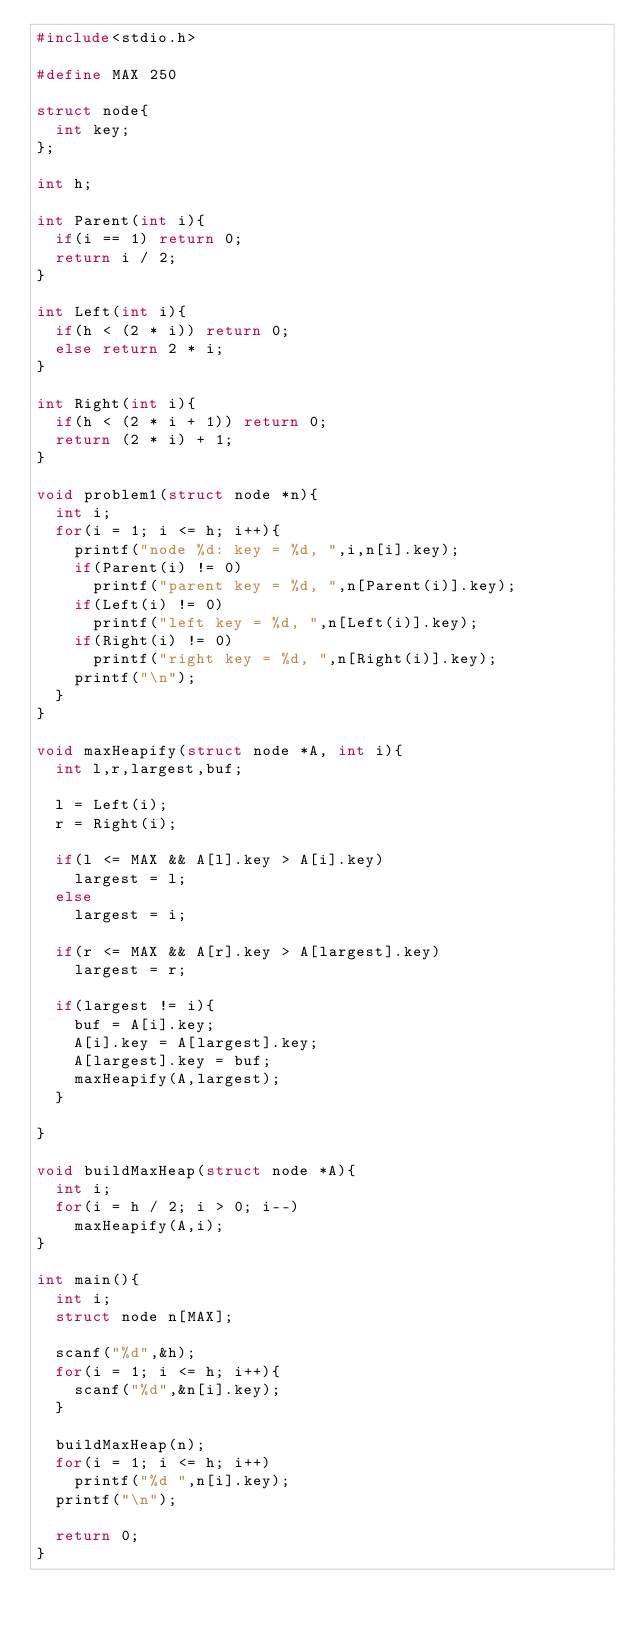Convert code to text. <code><loc_0><loc_0><loc_500><loc_500><_C_>#include<stdio.h>

#define MAX 250

struct node{
  int key;
};

int h;

int Parent(int i){
  if(i == 1) return 0;
  return i / 2;
}

int Left(int i){
  if(h < (2 * i)) return 0;
  else return 2 * i;
}

int Right(int i){
  if(h < (2 * i + 1)) return 0;
  return (2 * i) + 1;
}

void problem1(struct node *n){
  int i;
  for(i = 1; i <= h; i++){
    printf("node %d: key = %d, ",i,n[i].key);
    if(Parent(i) != 0)
      printf("parent key = %d, ",n[Parent(i)].key);
    if(Left(i) != 0)
      printf("left key = %d, ",n[Left(i)].key);
    if(Right(i) != 0)
      printf("right key = %d, ",n[Right(i)].key);
    printf("\n");
  }
}

void maxHeapify(struct node *A, int i){
  int l,r,largest,buf;

  l = Left(i);
  r = Right(i);

  if(l <= MAX && A[l].key > A[i].key)
    largest = l;
  else
    largest = i;

  if(r <= MAX && A[r].key > A[largest].key)
    largest = r;

  if(largest != i){
    buf = A[i].key;
    A[i].key = A[largest].key;
    A[largest].key = buf;
    maxHeapify(A,largest);
  }
    
}

void buildMaxHeap(struct node *A){
  int i;
  for(i = h / 2; i > 0; i--)
    maxHeapify(A,i);
}

int main(){
  int i;
  struct node n[MAX];

  scanf("%d",&h);
  for(i = 1; i <= h; i++){
    scanf("%d",&n[i].key);   
  }

  buildMaxHeap(n);
  for(i = 1; i <= h; i++)
    printf("%d ",n[i].key);
  printf("\n");
  
  return 0;
}

</code> 